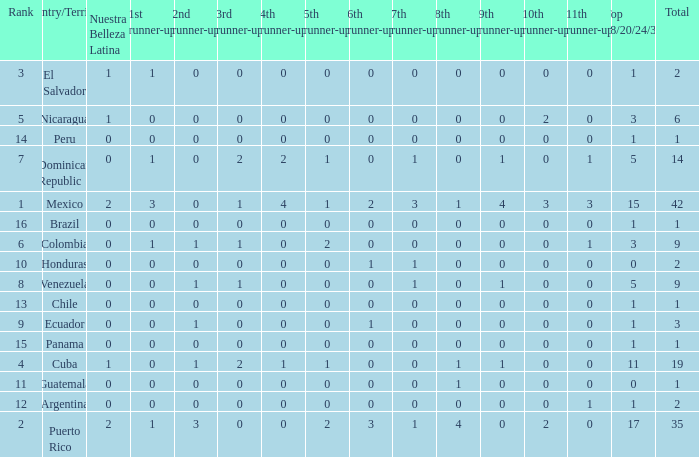What is the 3rd runner-up of the country with more than 0 9th runner-up, an 11th runner-up of 0, and the 1st runner-up greater than 0? None. 